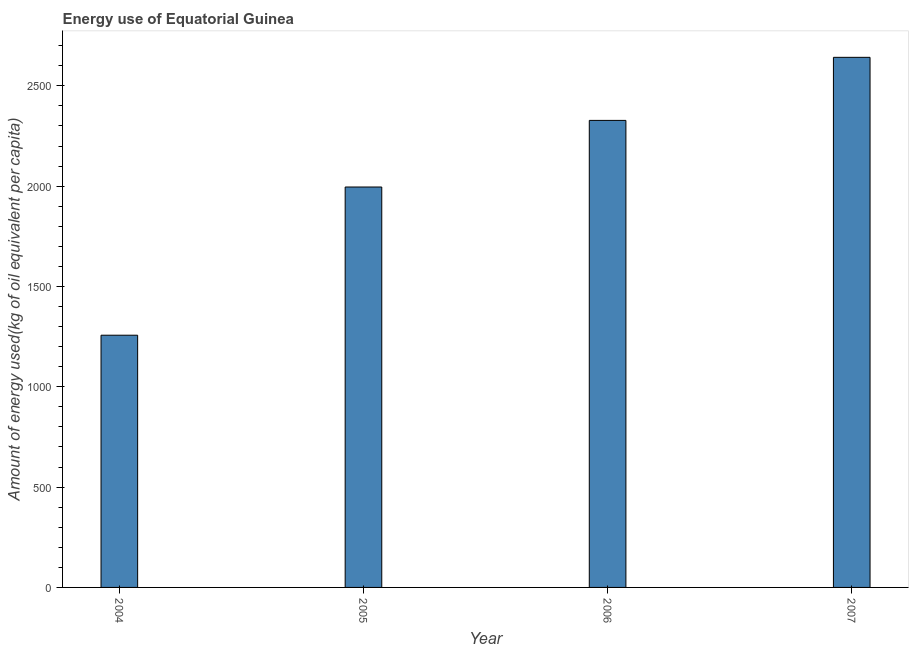Does the graph contain grids?
Your answer should be compact. No. What is the title of the graph?
Keep it short and to the point. Energy use of Equatorial Guinea. What is the label or title of the X-axis?
Provide a short and direct response. Year. What is the label or title of the Y-axis?
Provide a succinct answer. Amount of energy used(kg of oil equivalent per capita). What is the amount of energy used in 2005?
Your response must be concise. 1995.63. Across all years, what is the maximum amount of energy used?
Your answer should be very brief. 2641.94. Across all years, what is the minimum amount of energy used?
Your answer should be compact. 1257.01. What is the sum of the amount of energy used?
Provide a succinct answer. 8222.23. What is the difference between the amount of energy used in 2004 and 2005?
Your response must be concise. -738.63. What is the average amount of energy used per year?
Give a very brief answer. 2055.56. What is the median amount of energy used?
Offer a very short reply. 2161.64. What is the ratio of the amount of energy used in 2004 to that in 2006?
Keep it short and to the point. 0.54. Is the difference between the amount of energy used in 2005 and 2006 greater than the difference between any two years?
Make the answer very short. No. What is the difference between the highest and the second highest amount of energy used?
Provide a succinct answer. 314.3. What is the difference between the highest and the lowest amount of energy used?
Ensure brevity in your answer.  1384.93. Are all the bars in the graph horizontal?
Keep it short and to the point. No. How many years are there in the graph?
Provide a short and direct response. 4. Are the values on the major ticks of Y-axis written in scientific E-notation?
Keep it short and to the point. No. What is the Amount of energy used(kg of oil equivalent per capita) of 2004?
Provide a short and direct response. 1257.01. What is the Amount of energy used(kg of oil equivalent per capita) in 2005?
Your response must be concise. 1995.63. What is the Amount of energy used(kg of oil equivalent per capita) in 2006?
Offer a very short reply. 2327.64. What is the Amount of energy used(kg of oil equivalent per capita) in 2007?
Keep it short and to the point. 2641.94. What is the difference between the Amount of energy used(kg of oil equivalent per capita) in 2004 and 2005?
Offer a terse response. -738.63. What is the difference between the Amount of energy used(kg of oil equivalent per capita) in 2004 and 2006?
Provide a succinct answer. -1070.63. What is the difference between the Amount of energy used(kg of oil equivalent per capita) in 2004 and 2007?
Keep it short and to the point. -1384.93. What is the difference between the Amount of energy used(kg of oil equivalent per capita) in 2005 and 2006?
Keep it short and to the point. -332.01. What is the difference between the Amount of energy used(kg of oil equivalent per capita) in 2005 and 2007?
Ensure brevity in your answer.  -646.31. What is the difference between the Amount of energy used(kg of oil equivalent per capita) in 2006 and 2007?
Your answer should be compact. -314.3. What is the ratio of the Amount of energy used(kg of oil equivalent per capita) in 2004 to that in 2005?
Make the answer very short. 0.63. What is the ratio of the Amount of energy used(kg of oil equivalent per capita) in 2004 to that in 2006?
Your response must be concise. 0.54. What is the ratio of the Amount of energy used(kg of oil equivalent per capita) in 2004 to that in 2007?
Provide a short and direct response. 0.48. What is the ratio of the Amount of energy used(kg of oil equivalent per capita) in 2005 to that in 2006?
Offer a terse response. 0.86. What is the ratio of the Amount of energy used(kg of oil equivalent per capita) in 2005 to that in 2007?
Offer a terse response. 0.76. What is the ratio of the Amount of energy used(kg of oil equivalent per capita) in 2006 to that in 2007?
Offer a terse response. 0.88. 